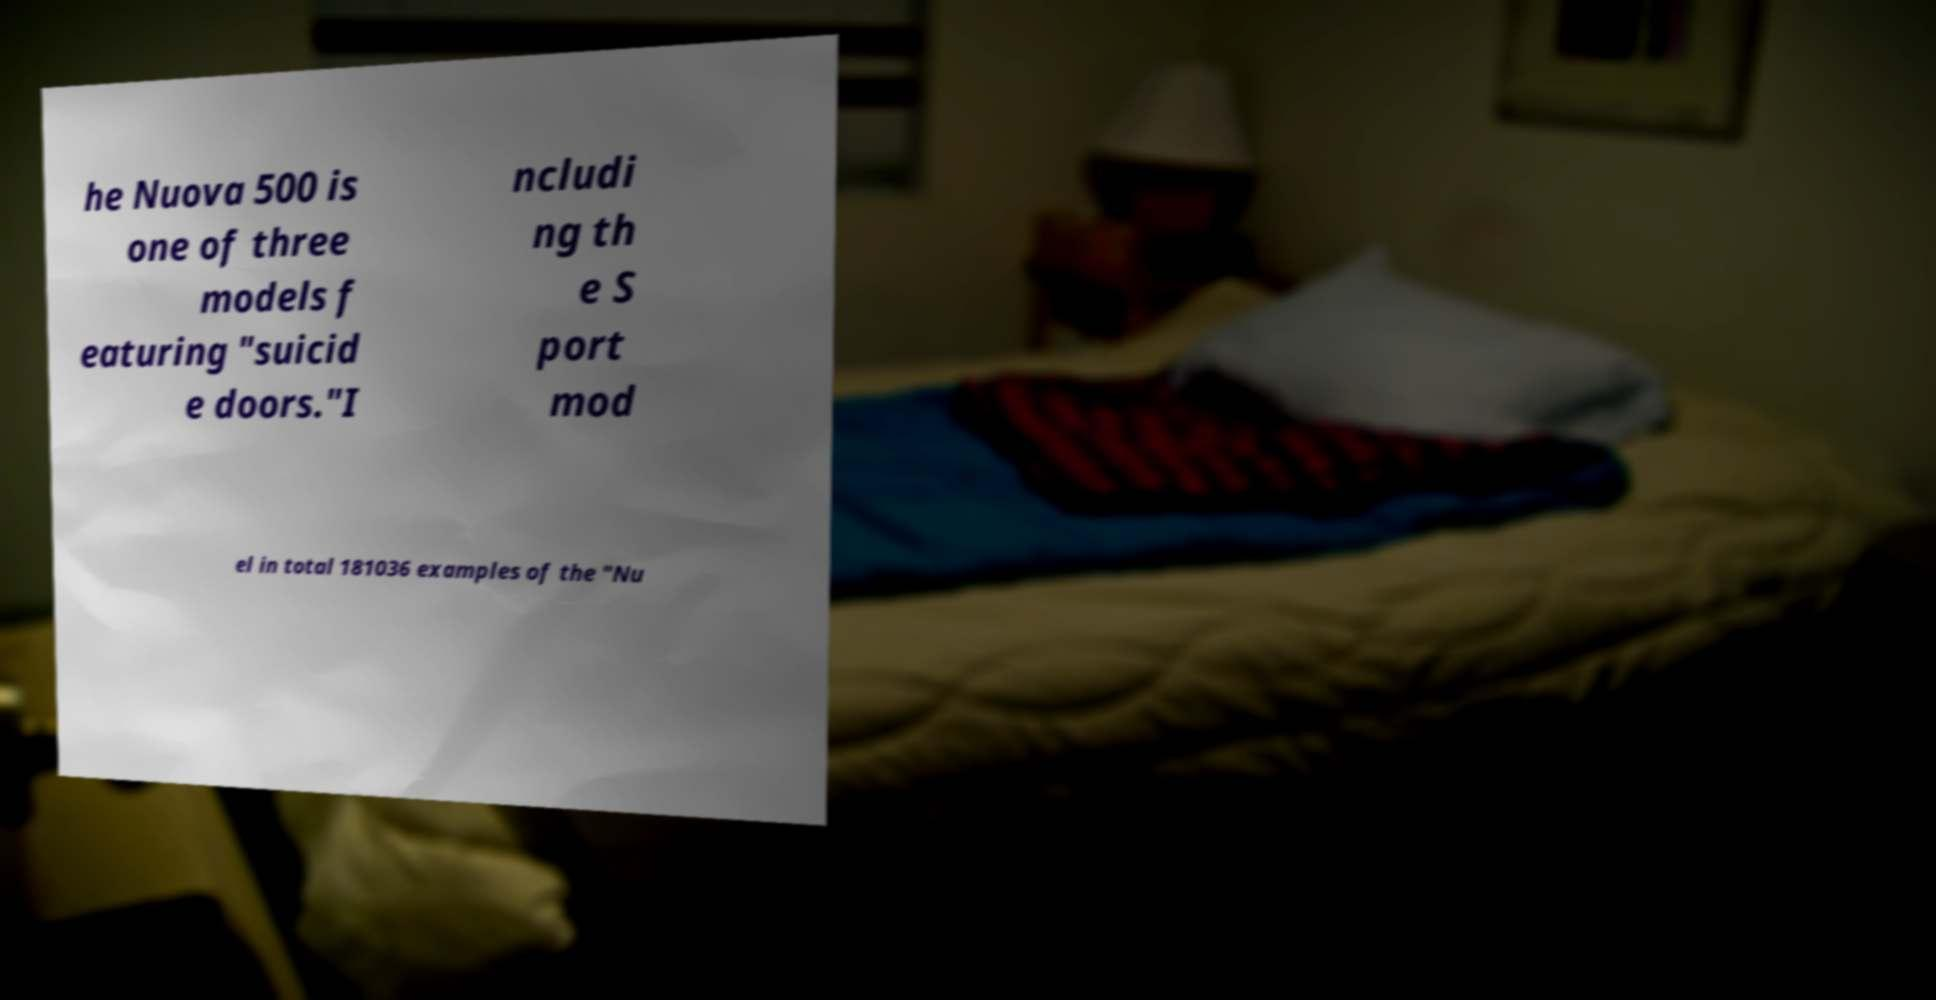I need the written content from this picture converted into text. Can you do that? he Nuova 500 is one of three models f eaturing "suicid e doors."I ncludi ng th e S port mod el in total 181036 examples of the "Nu 